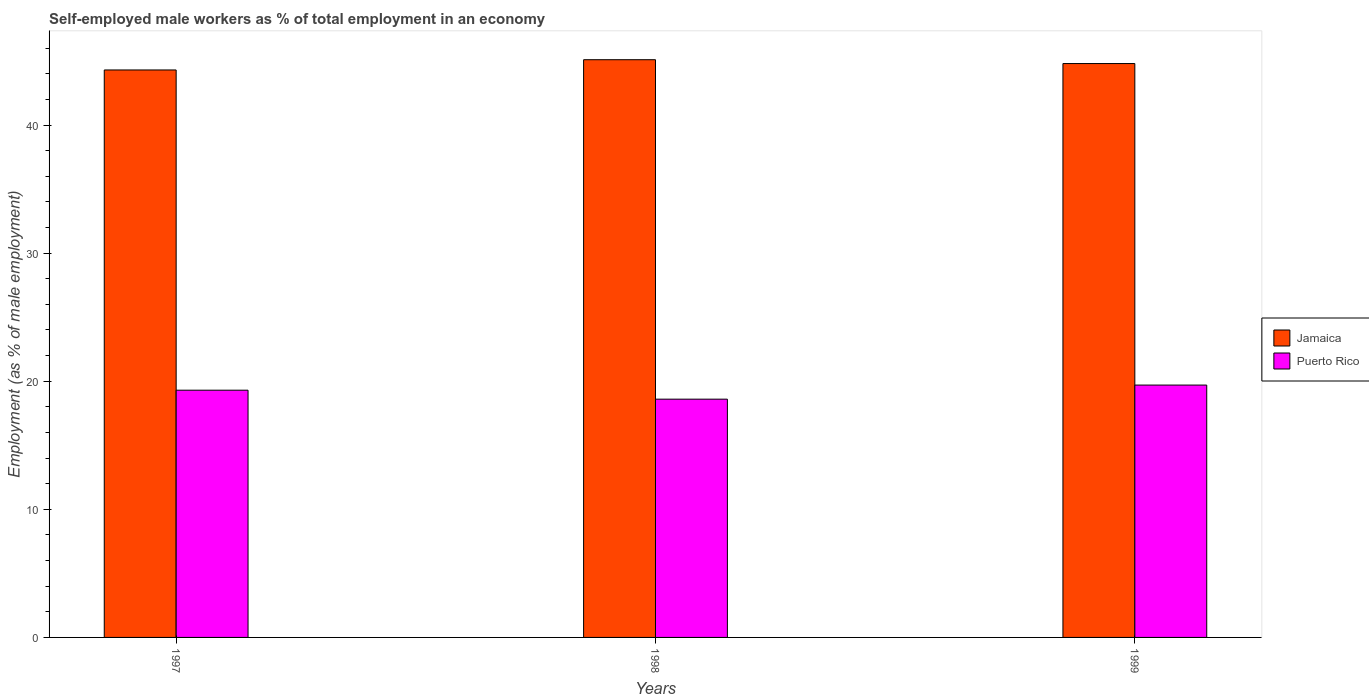How many groups of bars are there?
Make the answer very short. 3. Are the number of bars per tick equal to the number of legend labels?
Your answer should be compact. Yes. What is the percentage of self-employed male workers in Jamaica in 1999?
Make the answer very short. 44.8. Across all years, what is the maximum percentage of self-employed male workers in Puerto Rico?
Keep it short and to the point. 19.7. Across all years, what is the minimum percentage of self-employed male workers in Puerto Rico?
Your response must be concise. 18.6. In which year was the percentage of self-employed male workers in Puerto Rico minimum?
Provide a short and direct response. 1998. What is the total percentage of self-employed male workers in Puerto Rico in the graph?
Your response must be concise. 57.6. What is the difference between the percentage of self-employed male workers in Puerto Rico in 1997 and that in 1999?
Provide a short and direct response. -0.4. What is the difference between the percentage of self-employed male workers in Puerto Rico in 1998 and the percentage of self-employed male workers in Jamaica in 1999?
Your answer should be very brief. -26.2. What is the average percentage of self-employed male workers in Jamaica per year?
Provide a short and direct response. 44.73. In the year 1999, what is the difference between the percentage of self-employed male workers in Puerto Rico and percentage of self-employed male workers in Jamaica?
Make the answer very short. -25.1. In how many years, is the percentage of self-employed male workers in Jamaica greater than 38 %?
Provide a short and direct response. 3. What is the ratio of the percentage of self-employed male workers in Puerto Rico in 1997 to that in 1999?
Offer a very short reply. 0.98. Is the percentage of self-employed male workers in Jamaica in 1998 less than that in 1999?
Your response must be concise. No. Is the difference between the percentage of self-employed male workers in Puerto Rico in 1997 and 1998 greater than the difference between the percentage of self-employed male workers in Jamaica in 1997 and 1998?
Provide a short and direct response. Yes. What is the difference between the highest and the second highest percentage of self-employed male workers in Jamaica?
Provide a succinct answer. 0.3. What is the difference between the highest and the lowest percentage of self-employed male workers in Puerto Rico?
Your answer should be compact. 1.1. In how many years, is the percentage of self-employed male workers in Jamaica greater than the average percentage of self-employed male workers in Jamaica taken over all years?
Make the answer very short. 2. Is the sum of the percentage of self-employed male workers in Jamaica in 1997 and 1999 greater than the maximum percentage of self-employed male workers in Puerto Rico across all years?
Give a very brief answer. Yes. What does the 1st bar from the left in 1997 represents?
Offer a very short reply. Jamaica. What does the 1st bar from the right in 1998 represents?
Ensure brevity in your answer.  Puerto Rico. How many bars are there?
Provide a succinct answer. 6. Are the values on the major ticks of Y-axis written in scientific E-notation?
Provide a succinct answer. No. Does the graph contain grids?
Make the answer very short. No. How many legend labels are there?
Your answer should be compact. 2. What is the title of the graph?
Your response must be concise. Self-employed male workers as % of total employment in an economy. Does "Burundi" appear as one of the legend labels in the graph?
Your answer should be very brief. No. What is the label or title of the Y-axis?
Provide a short and direct response. Employment (as % of male employment). What is the Employment (as % of male employment) in Jamaica in 1997?
Offer a very short reply. 44.3. What is the Employment (as % of male employment) of Puerto Rico in 1997?
Offer a terse response. 19.3. What is the Employment (as % of male employment) of Jamaica in 1998?
Your response must be concise. 45.1. What is the Employment (as % of male employment) in Puerto Rico in 1998?
Offer a very short reply. 18.6. What is the Employment (as % of male employment) of Jamaica in 1999?
Give a very brief answer. 44.8. What is the Employment (as % of male employment) in Puerto Rico in 1999?
Offer a terse response. 19.7. Across all years, what is the maximum Employment (as % of male employment) of Jamaica?
Make the answer very short. 45.1. Across all years, what is the maximum Employment (as % of male employment) in Puerto Rico?
Offer a terse response. 19.7. Across all years, what is the minimum Employment (as % of male employment) in Jamaica?
Provide a succinct answer. 44.3. Across all years, what is the minimum Employment (as % of male employment) in Puerto Rico?
Offer a very short reply. 18.6. What is the total Employment (as % of male employment) of Jamaica in the graph?
Offer a terse response. 134.2. What is the total Employment (as % of male employment) of Puerto Rico in the graph?
Give a very brief answer. 57.6. What is the difference between the Employment (as % of male employment) in Jamaica in 1998 and that in 1999?
Provide a succinct answer. 0.3. What is the difference between the Employment (as % of male employment) of Jamaica in 1997 and the Employment (as % of male employment) of Puerto Rico in 1998?
Give a very brief answer. 25.7. What is the difference between the Employment (as % of male employment) of Jamaica in 1997 and the Employment (as % of male employment) of Puerto Rico in 1999?
Make the answer very short. 24.6. What is the difference between the Employment (as % of male employment) of Jamaica in 1998 and the Employment (as % of male employment) of Puerto Rico in 1999?
Offer a very short reply. 25.4. What is the average Employment (as % of male employment) in Jamaica per year?
Offer a very short reply. 44.73. What is the average Employment (as % of male employment) of Puerto Rico per year?
Ensure brevity in your answer.  19.2. In the year 1999, what is the difference between the Employment (as % of male employment) in Jamaica and Employment (as % of male employment) in Puerto Rico?
Provide a short and direct response. 25.1. What is the ratio of the Employment (as % of male employment) of Jamaica in 1997 to that in 1998?
Your response must be concise. 0.98. What is the ratio of the Employment (as % of male employment) in Puerto Rico in 1997 to that in 1998?
Provide a succinct answer. 1.04. What is the ratio of the Employment (as % of male employment) in Jamaica in 1997 to that in 1999?
Ensure brevity in your answer.  0.99. What is the ratio of the Employment (as % of male employment) in Puerto Rico in 1997 to that in 1999?
Provide a short and direct response. 0.98. What is the ratio of the Employment (as % of male employment) of Puerto Rico in 1998 to that in 1999?
Keep it short and to the point. 0.94. What is the difference between the highest and the second highest Employment (as % of male employment) in Jamaica?
Your answer should be compact. 0.3. What is the difference between the highest and the second highest Employment (as % of male employment) of Puerto Rico?
Provide a succinct answer. 0.4. What is the difference between the highest and the lowest Employment (as % of male employment) of Puerto Rico?
Make the answer very short. 1.1. 